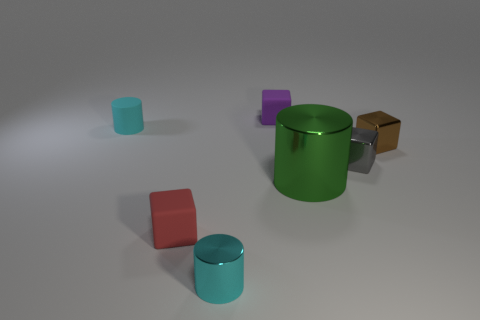Subtract 1 cylinders. How many cylinders are left? 2 Add 1 big objects. How many objects exist? 8 Subtract all cyan cylinders. How many cylinders are left? 1 Subtract all brown cubes. How many cubes are left? 3 Subtract all blue cubes. Subtract all purple spheres. How many cubes are left? 4 Subtract all cubes. How many objects are left? 3 Add 7 small brown cubes. How many small brown cubes exist? 8 Subtract 0 blue spheres. How many objects are left? 7 Subtract all small blocks. Subtract all tiny red matte things. How many objects are left? 2 Add 5 tiny cyan shiny cylinders. How many tiny cyan shiny cylinders are left? 6 